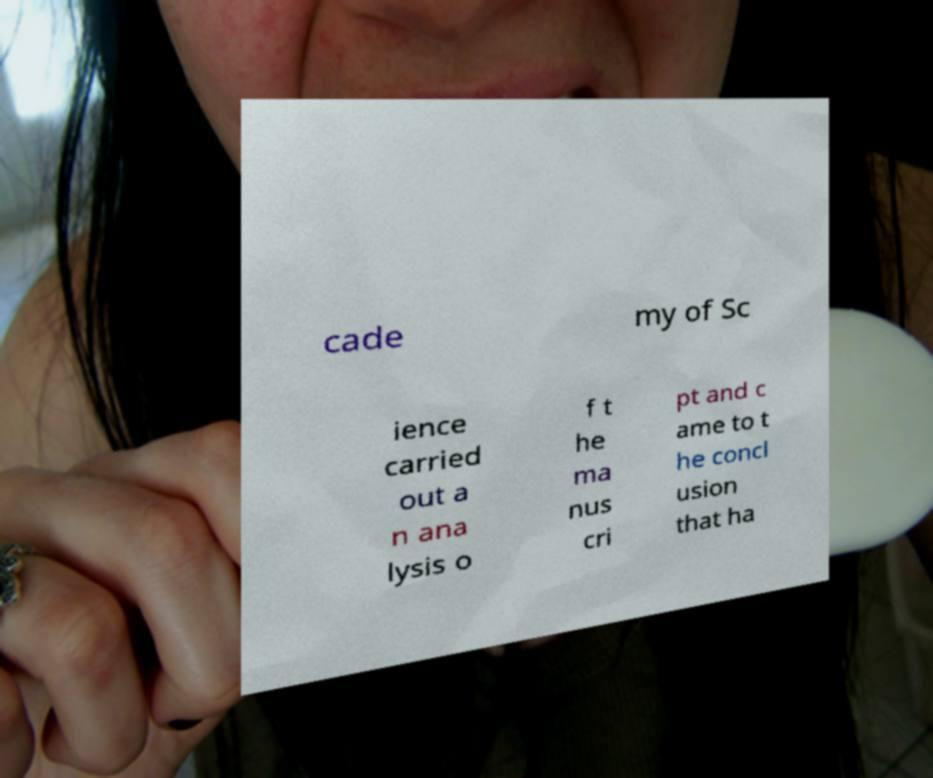Could you assist in decoding the text presented in this image and type it out clearly? cade my of Sc ience carried out a n ana lysis o f t he ma nus cri pt and c ame to t he concl usion that ha 